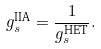<formula> <loc_0><loc_0><loc_500><loc_500>g _ { s } ^ { \text {IIA} } = \frac { 1 } { g _ { s } ^ { \text {HET} } } .</formula> 